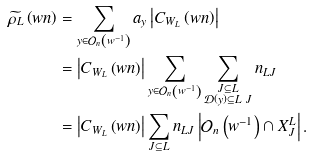<formula> <loc_0><loc_0><loc_500><loc_500>\widetilde { \rho _ { L } } \left ( w n \right ) & = \sum _ { y \in \mathcal { O } _ { n } \left ( w ^ { - 1 } \right ) } a _ { y } \left | C _ { W _ { L } } \left ( w n \right ) \right | \\ & = \left | C _ { W _ { L } } \left ( w n \right ) \right | \sum _ { y \in \mathcal { O } _ { n } \left ( w ^ { - 1 } \right ) } \sum _ { \substack { J \subseteq L \\ \mathcal { D } \left ( y \right ) \subseteq L \ J } } n _ { L J } \\ & = \left | C _ { W _ { L } } \left ( w n \right ) \right | \sum _ { J \subseteq L } n _ { L J } \left | \mathcal { O } _ { n } \left ( w ^ { - 1 } \right ) \cap X _ { J } ^ { L } \right | .</formula> 